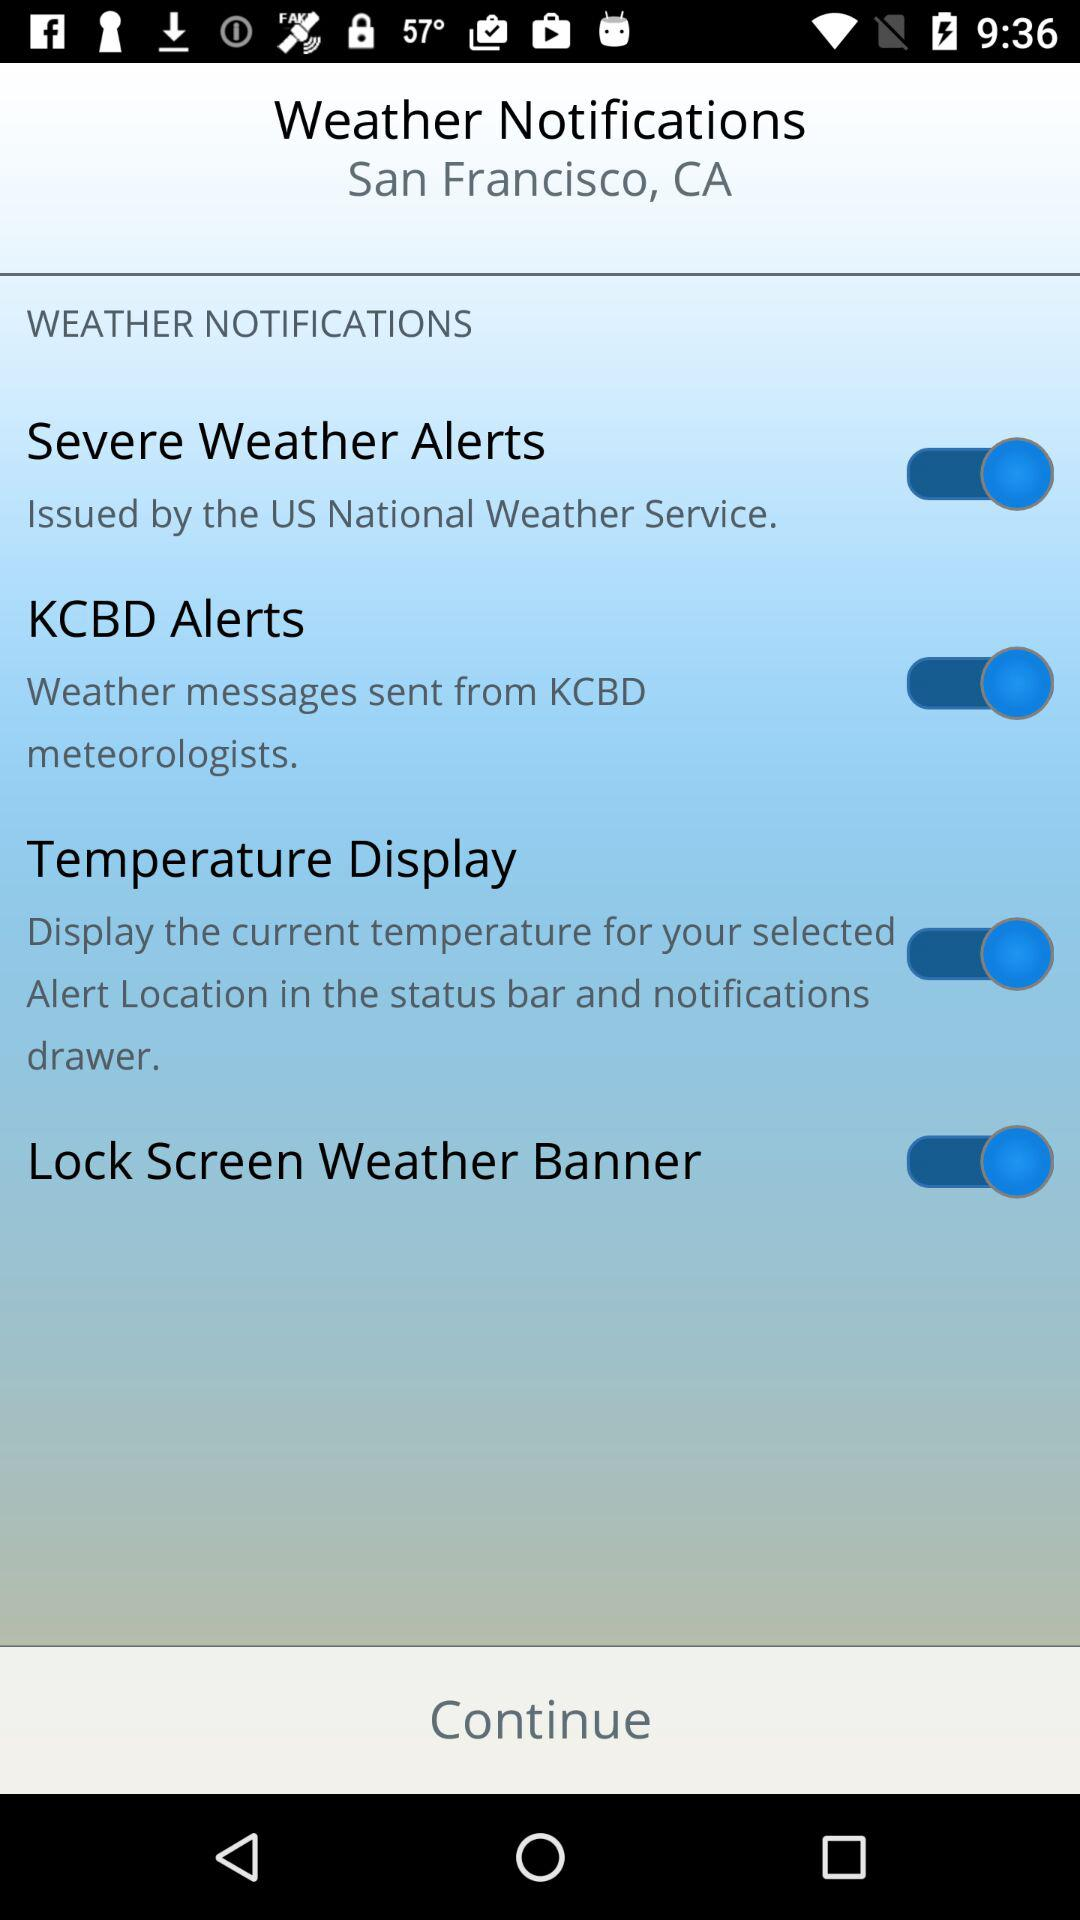What is the status of the "Temperature Display"? The status is "on". 